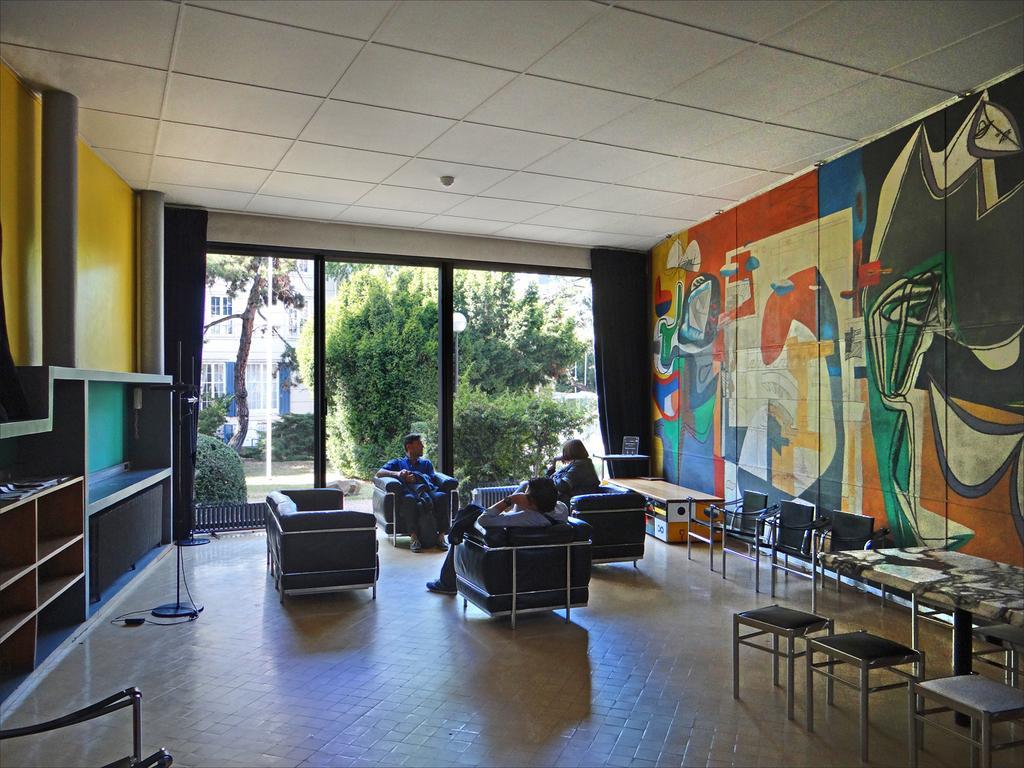In one or two sentences, can you explain what this image depicts? There are three persons sitting in a sofa and there are painted walls on the either side of them and in background there are trees and buildings. 